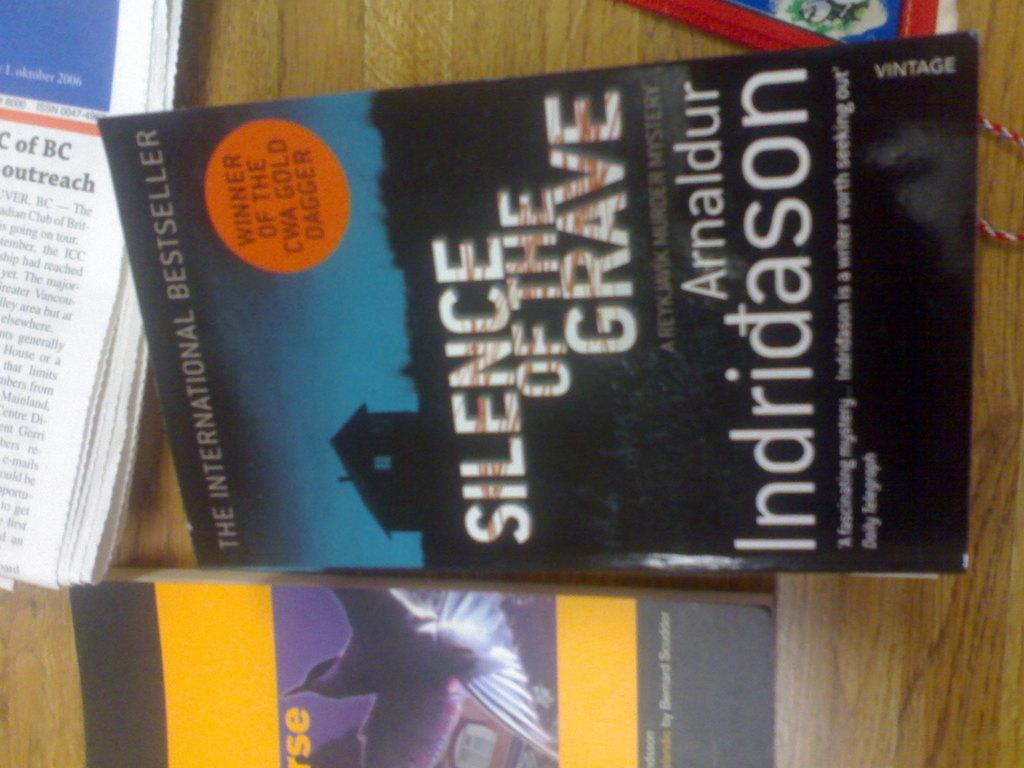Provide a one-sentence caption for the provided image. A wooden table with several books on it including one called Silence of the Grave. 